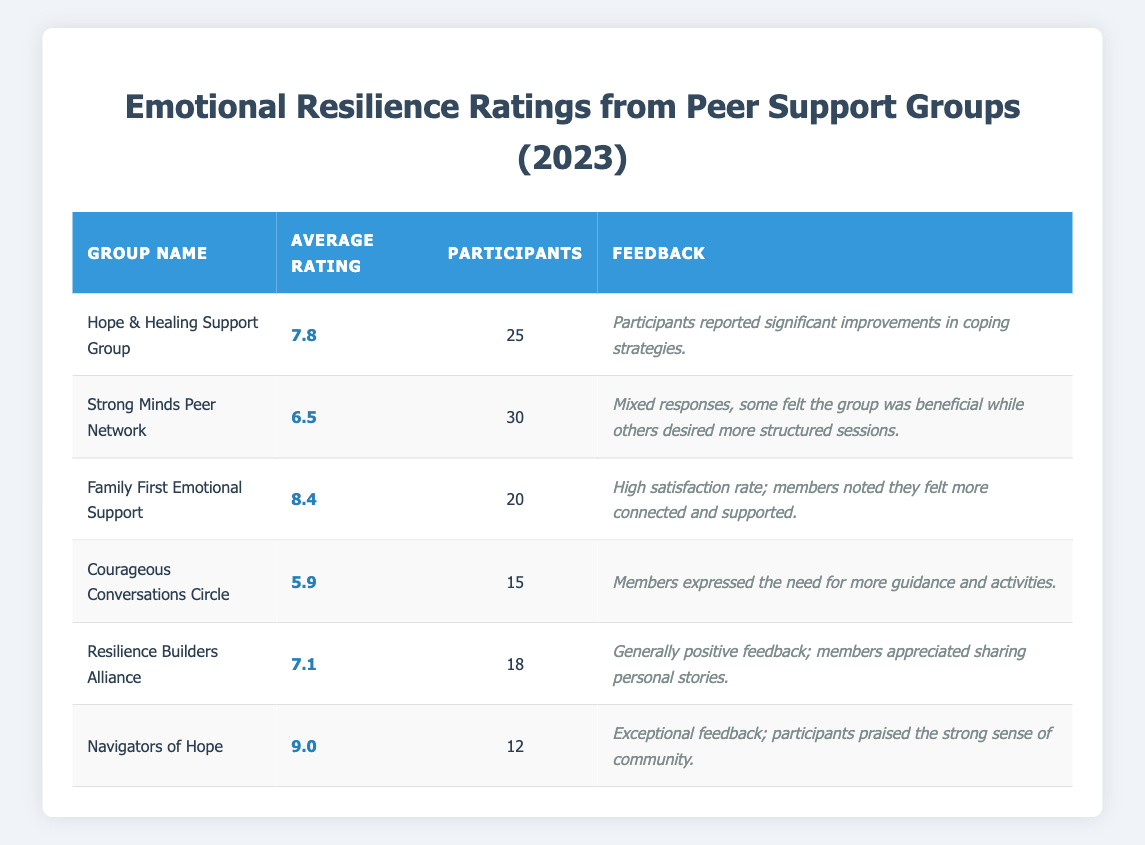What is the average rating of the Family First Emotional Support group? The table shows that the average rating for the Family First Emotional Support group is 8.4.
Answer: 8.4 Which support group had the highest number of participants? By comparing the participants in each group, the Strong Minds Peer Network has the highest number of participants, with 30 participants.
Answer: 30 Is it true that the Courageous Conversations Circle received an average rating below 6? The average rating for the Courageous Conversations Circle is 5.9, which is indeed below 6, so the statement is true.
Answer: True What is the difference between the average rating of Navigators of Hope and Courageous Conversations Circle? The average rating of Navigators of Hope is 9.0 and for Courageous Conversations Circle is 5.9. The difference is 9.0 - 5.9 = 3.1.
Answer: 3.1 How many total participants are in the Hope & Healing Support Group and Family First Emotional Support? The Hope & Healing Support Group has 25 participants and Family First Emotional Support has 20, so the total is 25 + 20 = 45 participants.
Answer: 45 Which group had the lowest average rating? Upon reviewing the average ratings, the Courageous Conversations Circle has the lowest average rating of 5.9.
Answer: 5.9 Are there more than 50 participants combined in all support groups? Adding the participants: 25 (Hope & Healing) + 30 (Strong Minds) + 20 (Family First) + 15 (Courageous Conversations) + 18 (Resilience Builders) + 12 (Navigators of Hope) totals to 25 + 30 + 20 + 15 + 18 + 12 = 130 participants, which is more than 50.
Answer: Yes Which group received feedback indicating members felt more connected? The Family First Emotional Support group received feedback indicating members felt more connected and supported.
Answer: Family First Emotional Support What is the average rating of all the support groups combined? To find the average, sum all the average ratings: 7.8 + 6.5 + 8.4 + 5.9 + 7.1 + 9.0 = 44.7, and then divide by the number of groups (6). The average is thus 44.7 / 6 ≈ 7.45.
Answer: 7.45 